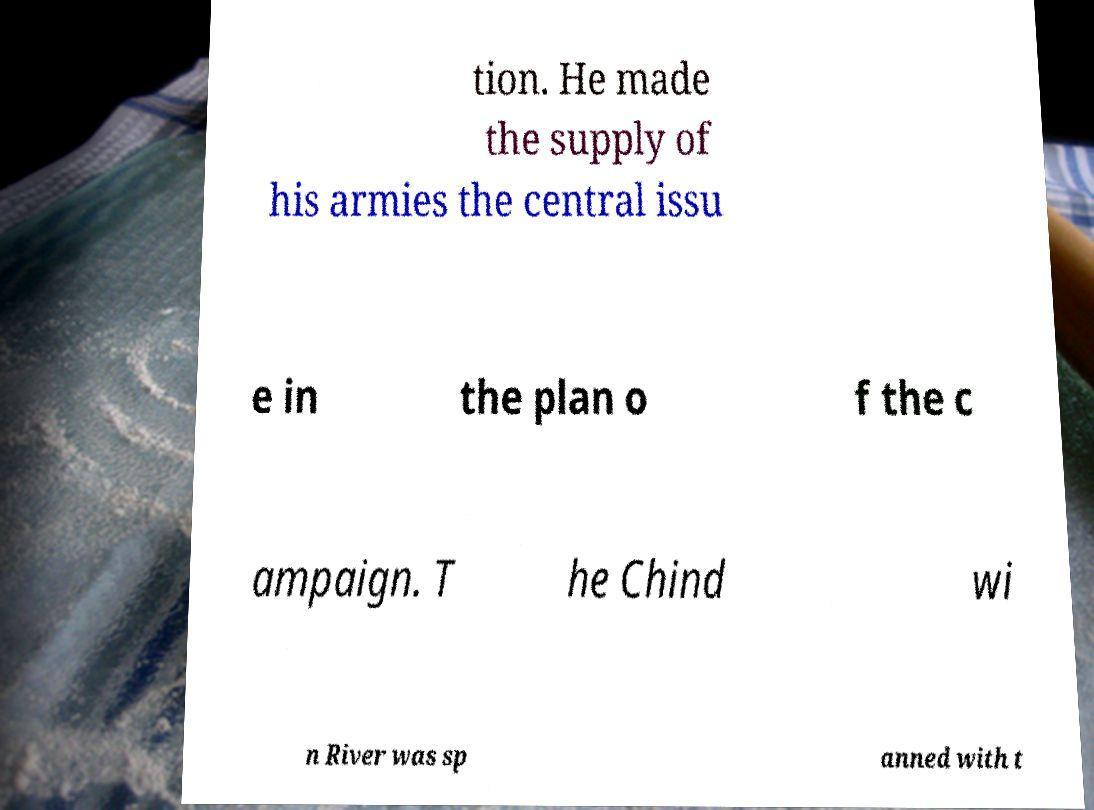Could you extract and type out the text from this image? tion. He made the supply of his armies the central issu e in the plan o f the c ampaign. T he Chind wi n River was sp anned with t 